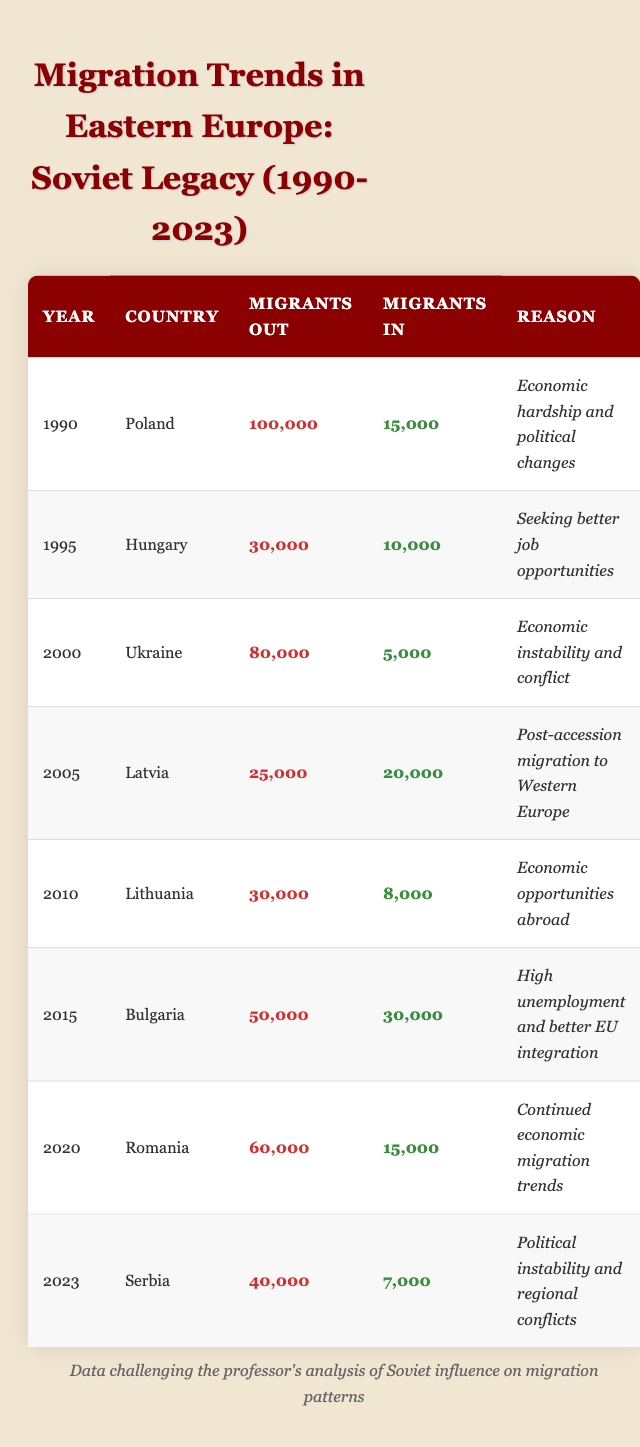What was the highest number of migrants out reported in the table? The data indicates that Poland had the highest number of migrants out in 1990, with a total of 100,000. I can identify this by scanning each year and observing the 'Migrants Out' values, finding that 100,000 is the largest.
Answer: 100,000 Which country had the lowest number of migrants in during the reported years? By checking the 'Migrants In' column for each country and year, Ukraine in 2000 reported only 5,000 migrants in, which is the lowest among all entries.
Answer: 5,000 What is the total number of migrants out from Bulgaria and Romania combined? To find this, I sum the number of migrants out for Bulgaria (50,000 in 2015) and Romania (60,000 in 2020). Adding these figures gives me 50,000 + 60,000 = 110,000.
Answer: 110,000 Did Latvia see a higher number of migrants in compared to migrants out in 2005? By comparing the respective values for Latvia in 2005, migrants out are 25,000 while migrants in are 20,000. Since 20,000 does not exceed 25,000, the assertion is false.
Answer: No In which year did Hungary have more migrants out compared to migrants in? By examining the data for Hungary in 1995, I see that the number of migrants out is 30,000, and migrants in is 10,000. Since 30,000 is greater than 10,000, this means that Hungary experienced more migrants out than in during that year.
Answer: 1995 What was the overall trend of migrants out across the years from 1990 to 2023? By analyzing the years, the number of migrants out varies, but largely there is a noticeable peak in early years, particularly in 1990 with 100,000 migrants out, declining to 40,000 in 2023. I can conclude that the overall trend shows decrease and variability over that time period.
Answer: Decreasing trend Calculate the difference in the number of migrants out between Ukraine in 2000 and Poland in 1990. In 1990, Poland had 100,000 migrants out, and in 2000, Ukraine had 80,000. The difference is calculated as 100,000 - 80,000 = 20,000, meaning Poland had significantly more out than Ukraine.
Answer: 20,000 Was there a year when Serbia had more migrants in than out? Looking at Serbia's data for 2023, the migrants in total is 7,000 compared to 40,000 out, which indicates that Serbia had more out than in, confirming a negative response to this query.
Answer: No 